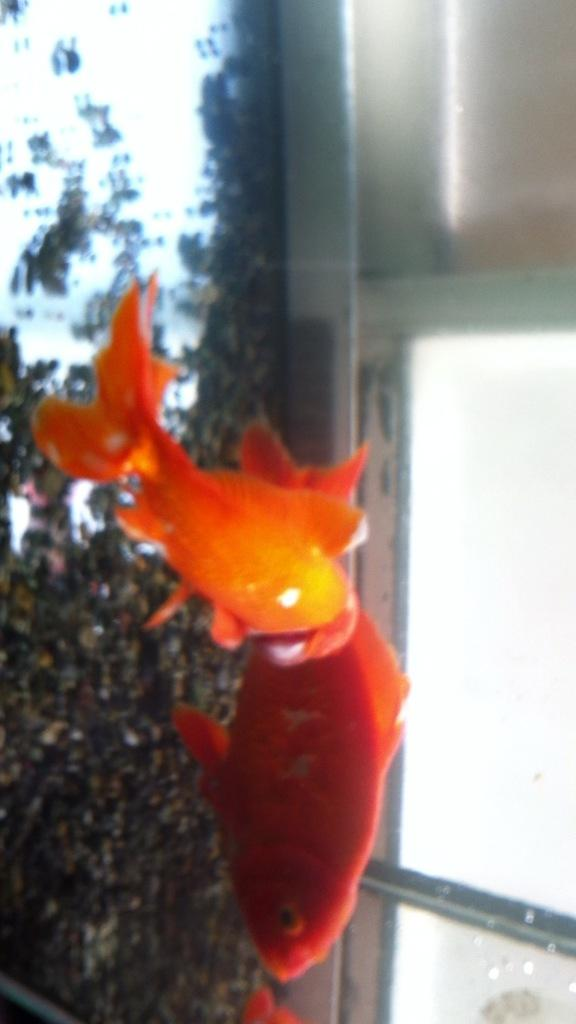What animals are present in the image? There are two fishes in the image. What color are the fishes? The fishes are orange in color. Where are the fishes located? The fishes are in the water. What type of pipe can be seen in the image? There is no pipe present in the image; it features two orange fishes in the water. What is the price of the jeans in the image? There are no jeans present in the image, so it is not possible to determine their price. 